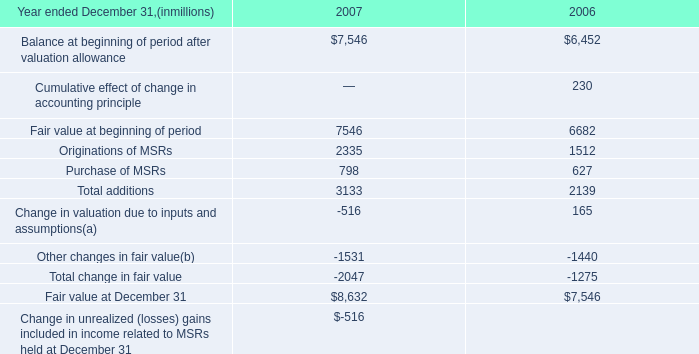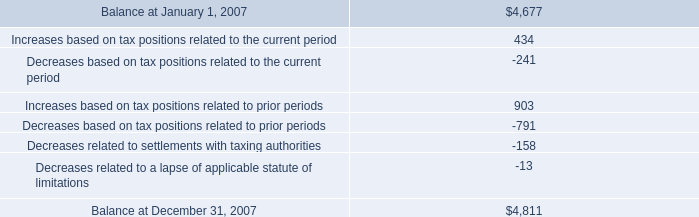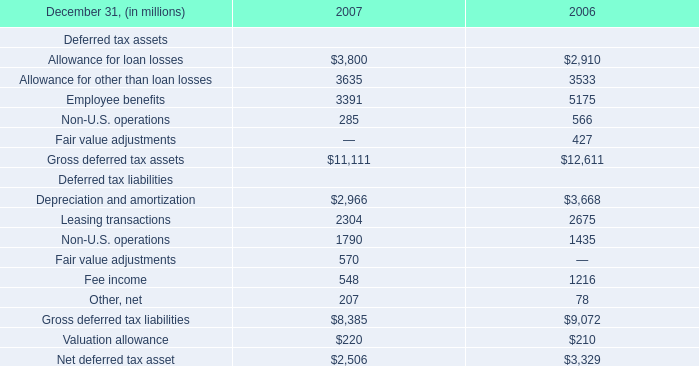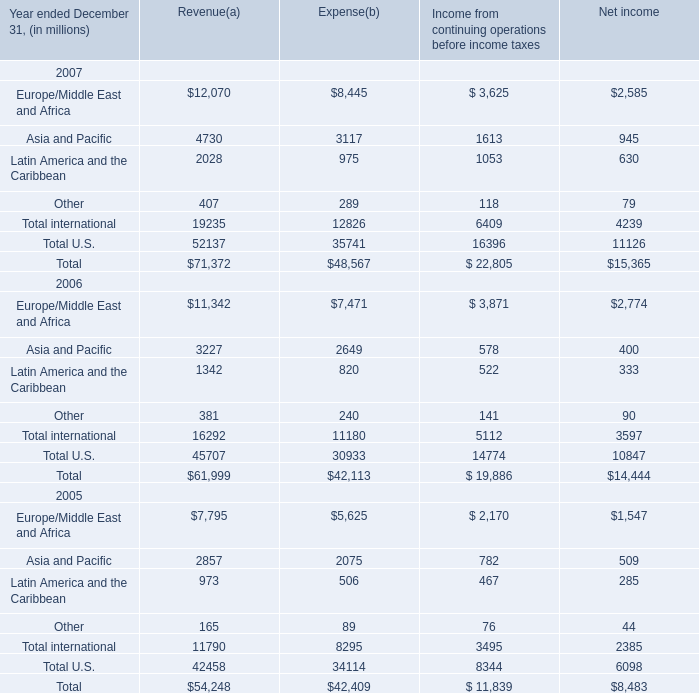How many Revenue exceed the average of Expense in 2007? 
Answer: 1. 